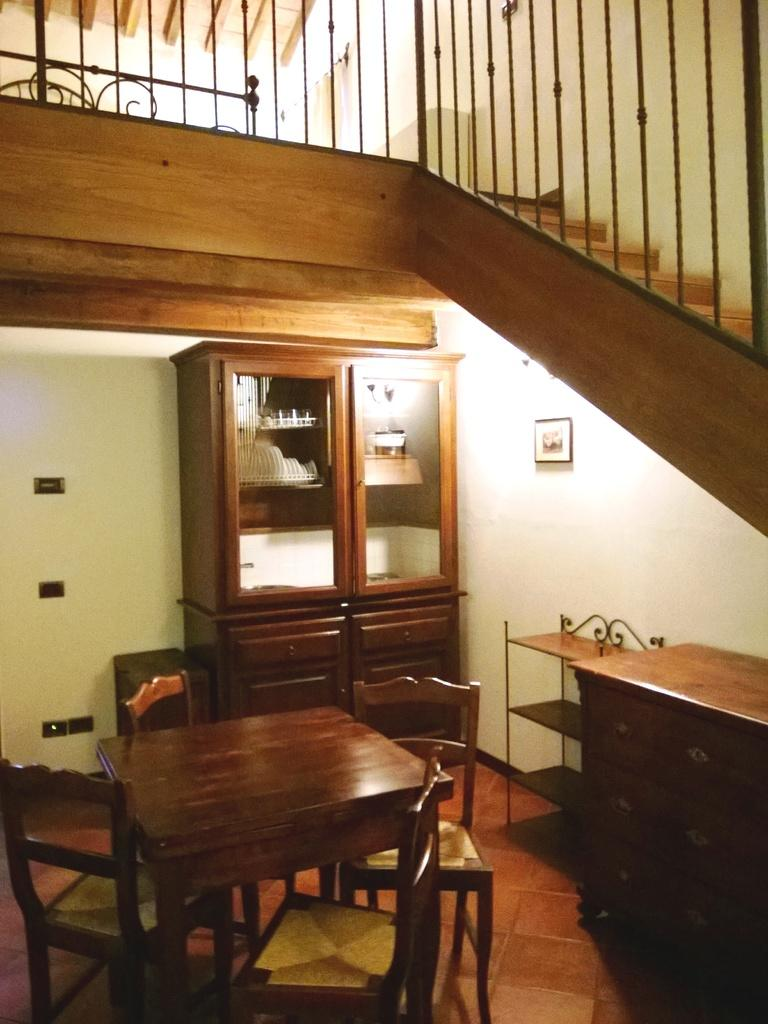What is hanging on the wall in the image? There is a photo frame on a wall in the image. What type of furniture is present in the image? There is a cupboard, chairs, and tables in the image. What architectural feature can be seen in the image? There are stairs in the image. What surface is visible in the image? The image shows a floor. What type of drink is being served on the stairs in the image? There is no drink being served in the image, as it only shows stairs and no indication of a drink being present. What type of apparel is being worn by the people in the image? There are no people visible in the image, so it is impossible to determine what type of apparel they might be wearing. 